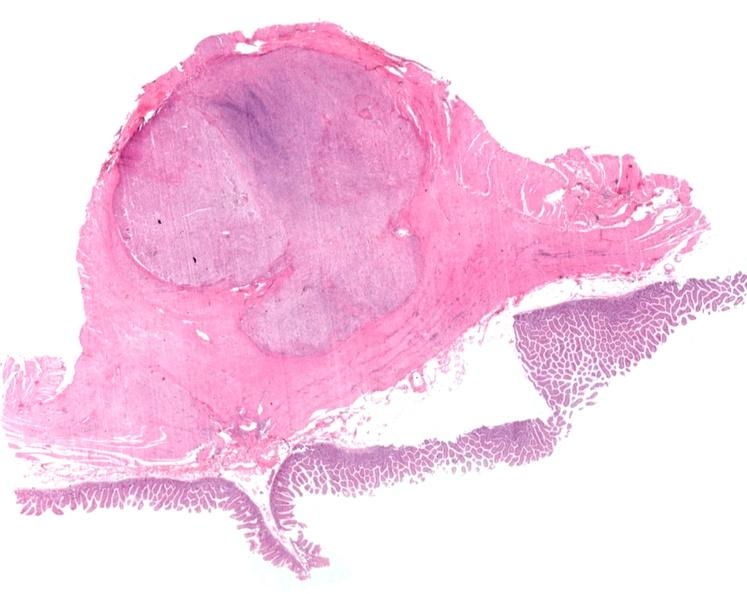does this image show stomach, leiomyoma with ulcerated mucosal surface?
Answer the question using a single word or phrase. Yes 